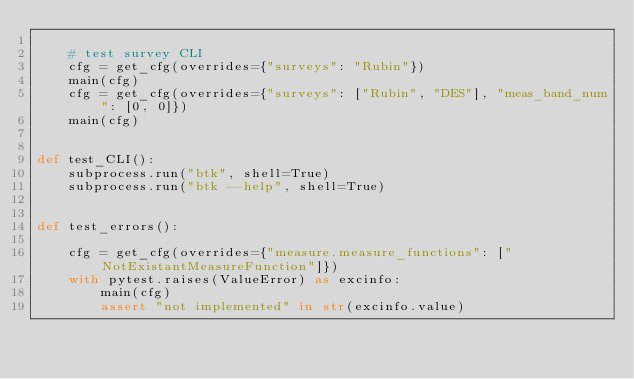Convert code to text. <code><loc_0><loc_0><loc_500><loc_500><_Python_>
    # test survey CLI
    cfg = get_cfg(overrides={"surveys": "Rubin"})
    main(cfg)
    cfg = get_cfg(overrides={"surveys": ["Rubin", "DES"], "meas_band_num": [0, 0]})
    main(cfg)


def test_CLI():
    subprocess.run("btk", shell=True)
    subprocess.run("btk --help", shell=True)


def test_errors():

    cfg = get_cfg(overrides={"measure.measure_functions": ["NotExistantMeasureFunction"]})
    with pytest.raises(ValueError) as excinfo:
        main(cfg)
        assert "not implemented" in str(excinfo.value)
</code> 